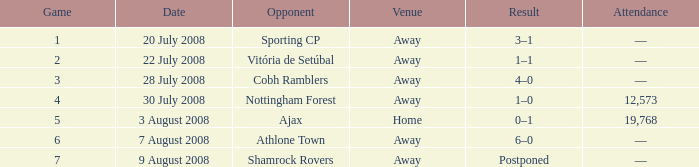What is the lowest game number on 20 July 2008? 1.0. 